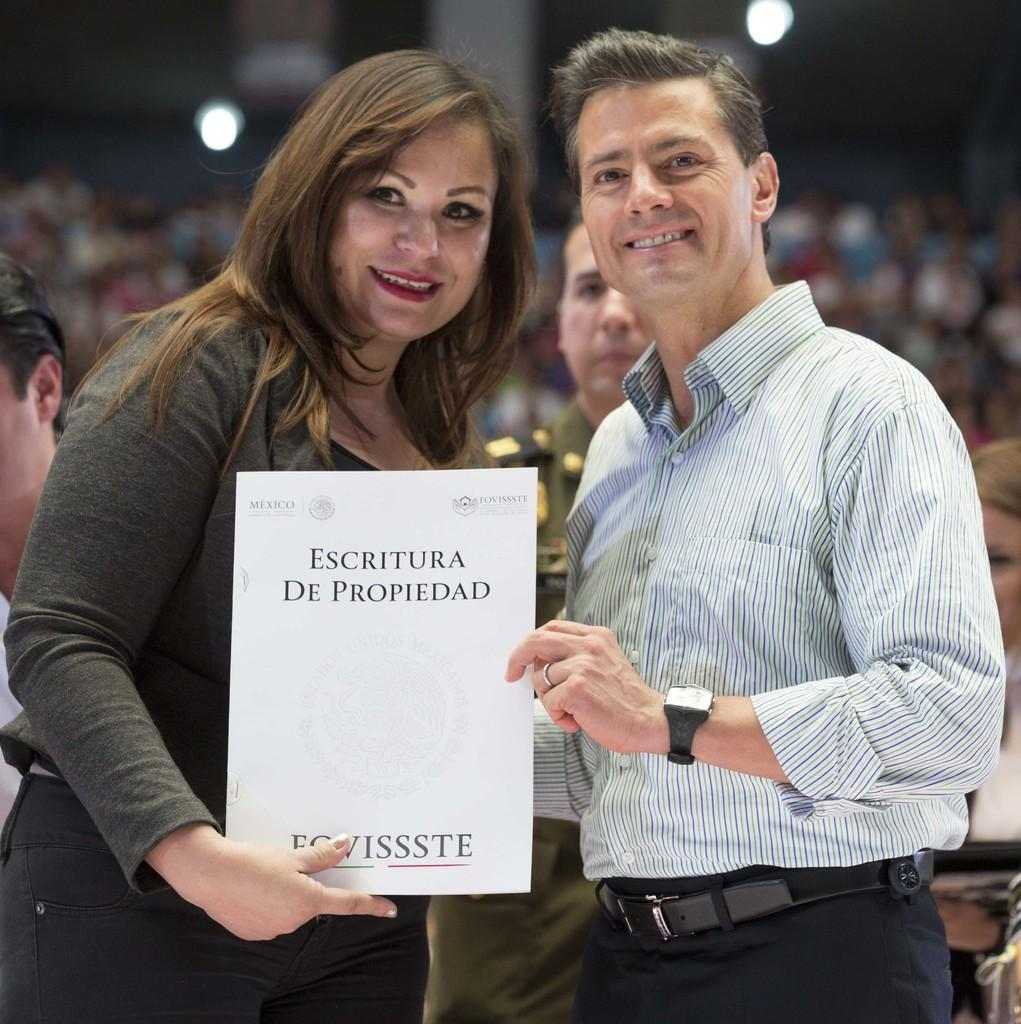How many people are present in the image? There are two people, a man and a woman, present in the image. What are the man and the woman doing in the image? Both the man and the woman are smiling and holding a paper. Can you describe the background of the image? The background is blurry and contains people, lights, and some objects. What type of watch is the man wearing in the image? There is no watch visible on the man in the image. What type of army is depicted in the background of the image? There is no army present in the image; the background contains people, lights, and some objects. 